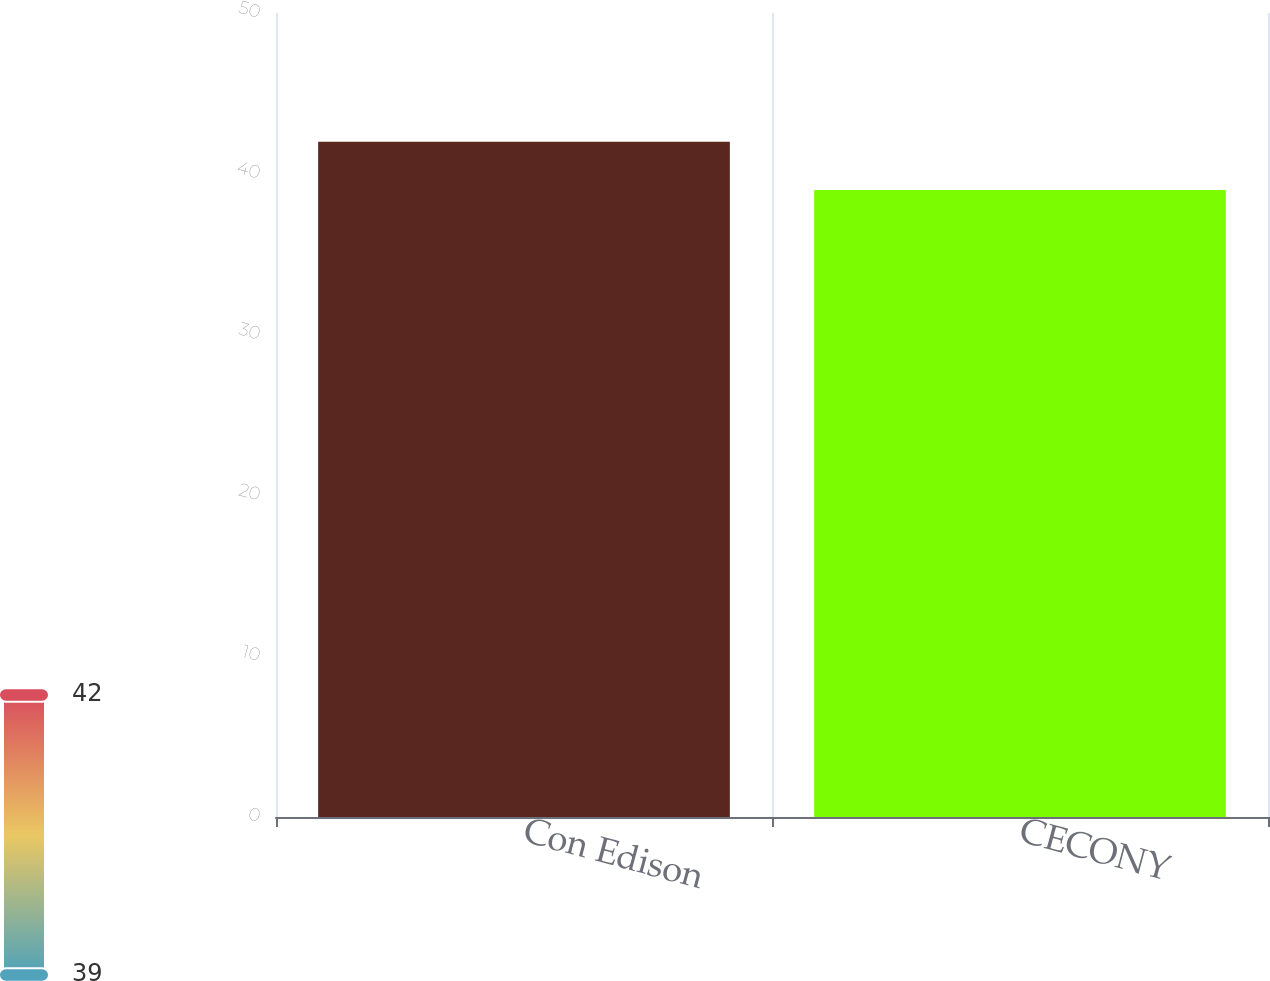<chart> <loc_0><loc_0><loc_500><loc_500><bar_chart><fcel>Con Edison<fcel>CECONY<nl><fcel>42<fcel>39<nl></chart> 